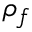<formula> <loc_0><loc_0><loc_500><loc_500>\rho _ { f }</formula> 